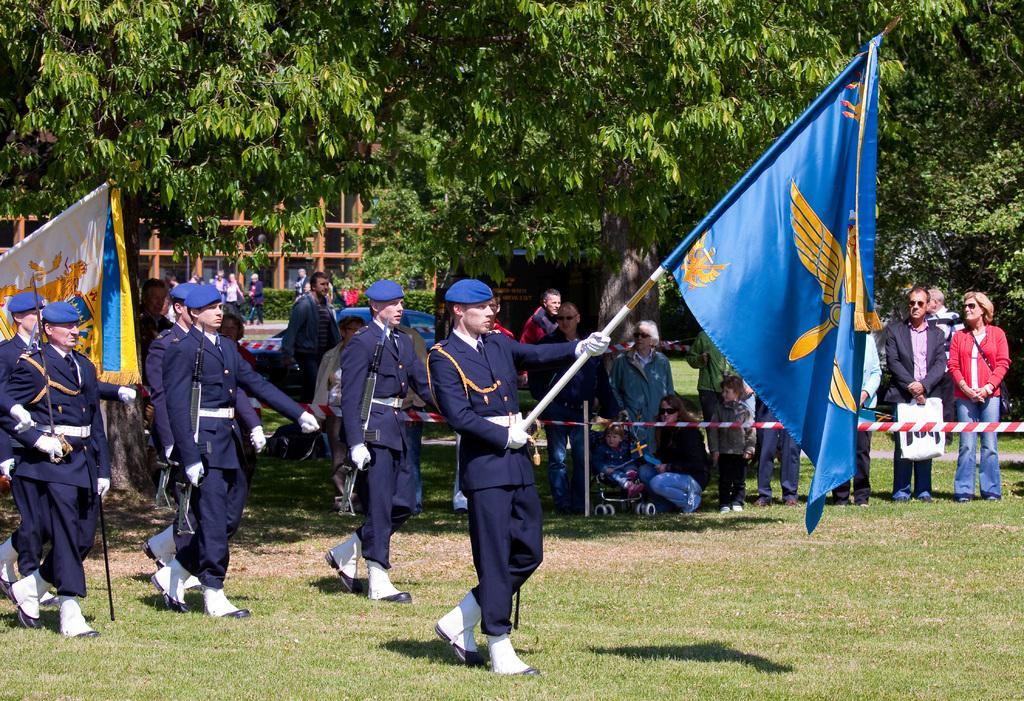Who are the people in the foreground of the picture? There are kids in the foreground of the picture. What can be seen in the foreground of the picture besides the kids? There are flags and grass in the foreground of the picture. What is visible in the background of the picture? There are trees, a construction, people, and plants in the background of the picture. Who is the owner of the news that is being produced in the image? There is no news or production of news present in the image. What type of produce can be seen growing in the background of the image? There is no produce visible in the image; only trees, a construction, people, and plants are present in the background. 